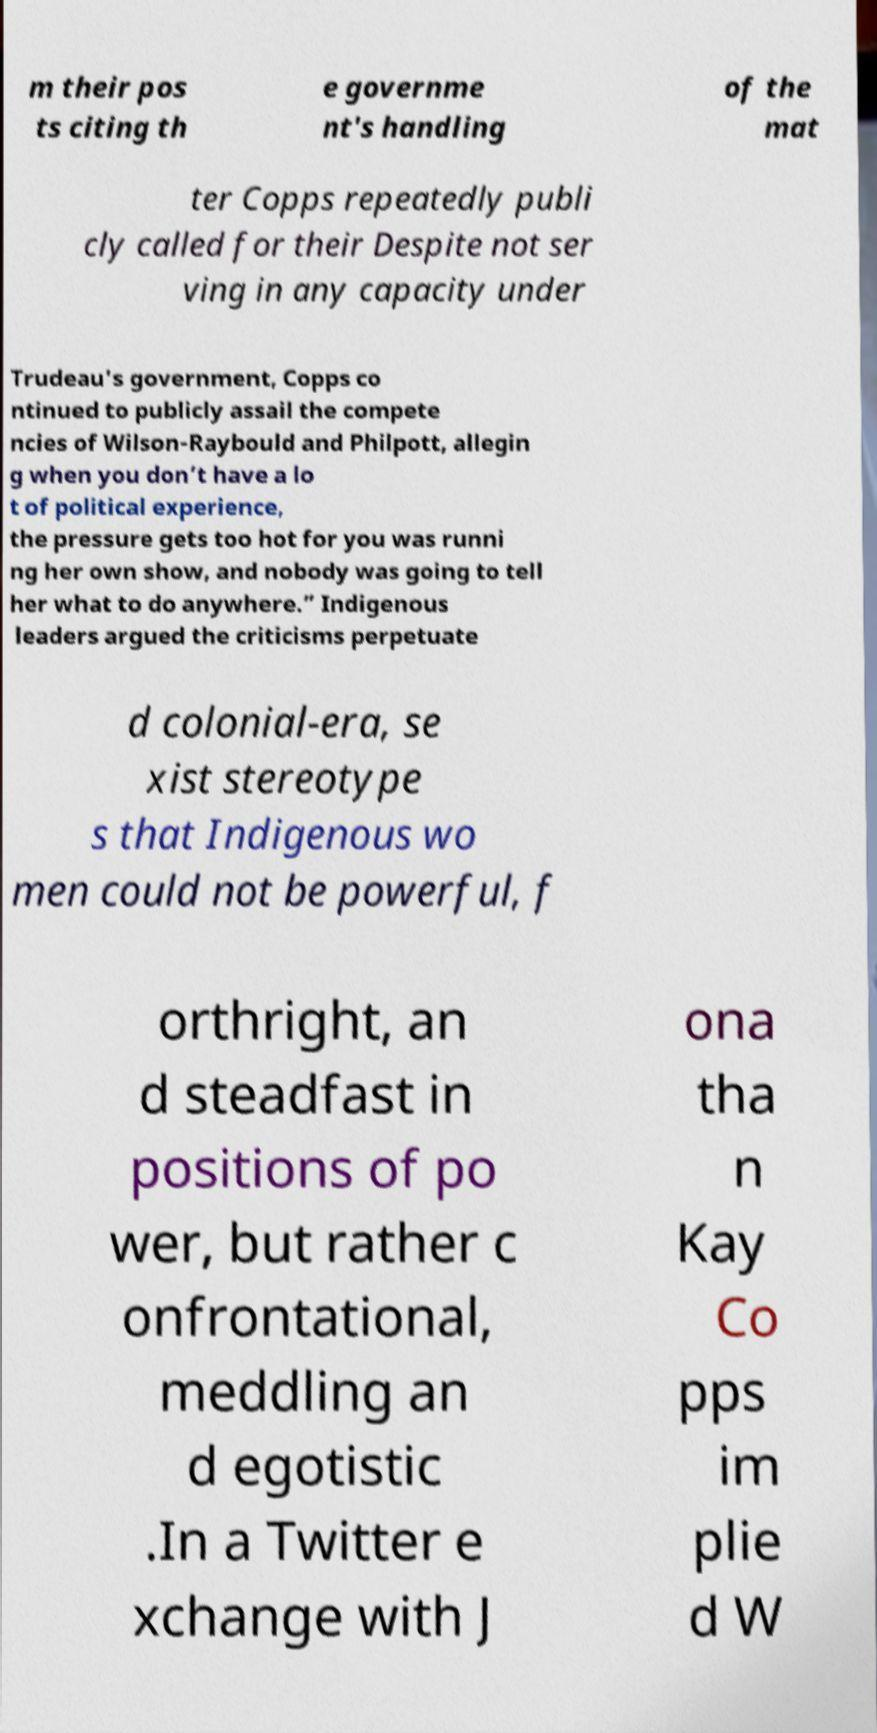Can you read and provide the text displayed in the image?This photo seems to have some interesting text. Can you extract and type it out for me? m their pos ts citing th e governme nt's handling of the mat ter Copps repeatedly publi cly called for their Despite not ser ving in any capacity under Trudeau's government, Copps co ntinued to publicly assail the compete ncies of Wilson-Raybould and Philpott, allegin g when you don’t have a lo t of political experience, the pressure gets too hot for you was runni ng her own show, and nobody was going to tell her what to do anywhere.” Indigenous leaders argued the criticisms perpetuate d colonial-era, se xist stereotype s that Indigenous wo men could not be powerful, f orthright, an d steadfast in positions of po wer, but rather c onfrontational, meddling an d egotistic .In a Twitter e xchange with J ona tha n Kay Co pps im plie d W 